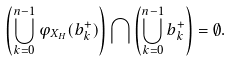<formula> <loc_0><loc_0><loc_500><loc_500>\left ( \bigcup _ { k = 0 } ^ { n - 1 } \varphi _ { X _ { H } } ( b ^ { + } _ { k } ) \right ) \bigcap \left ( \bigcup _ { k = 0 } ^ { n - 1 } b ^ { + } _ { k } \right ) = \emptyset .</formula> 